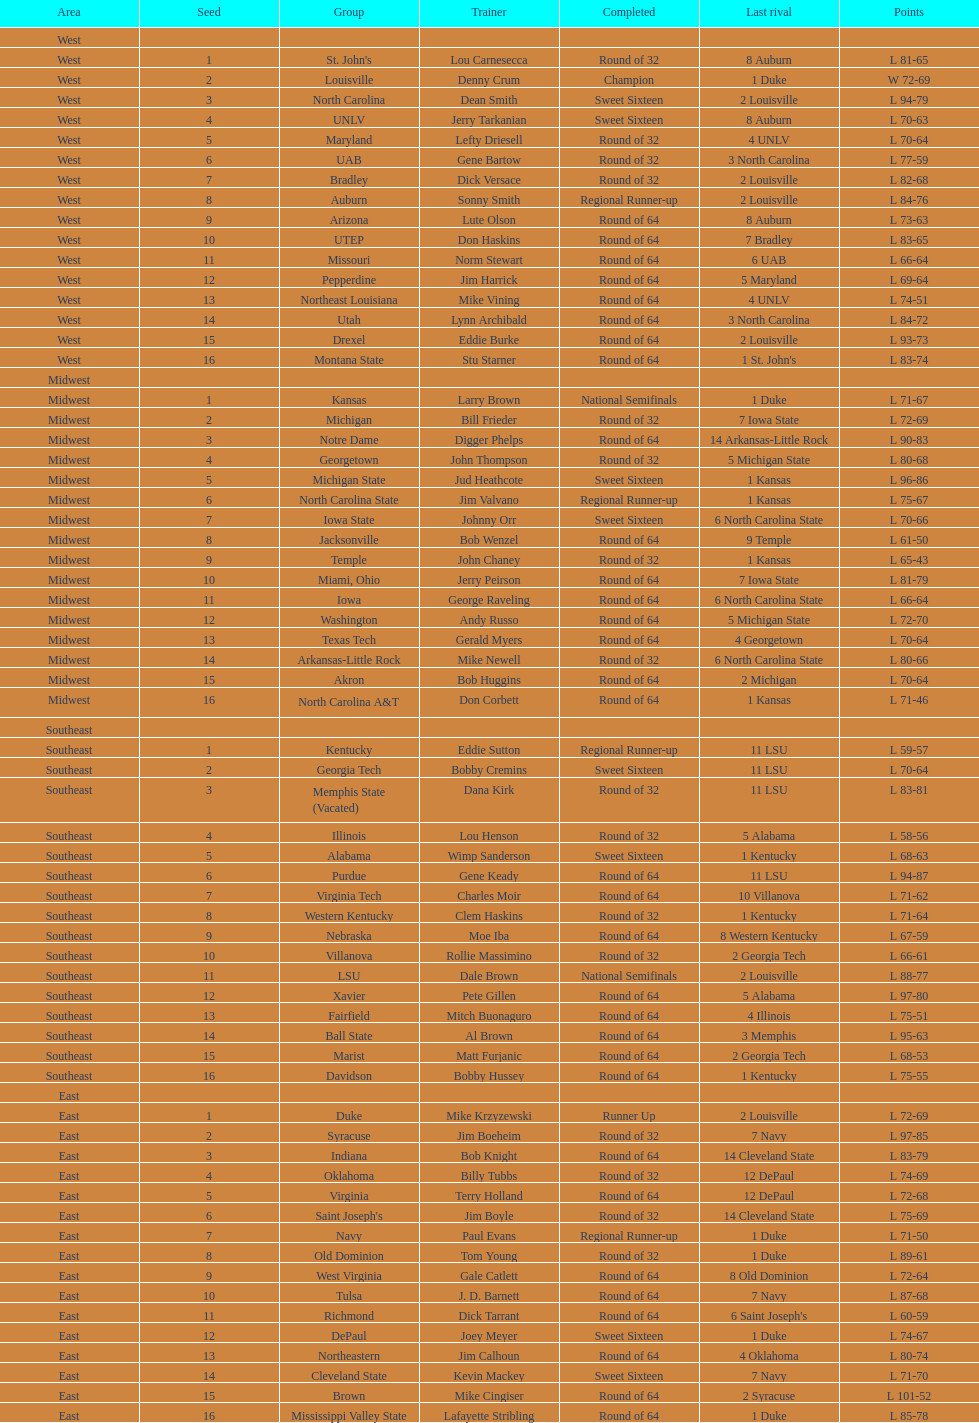North carolina and unlv each made it to which round? Sweet Sixteen. 